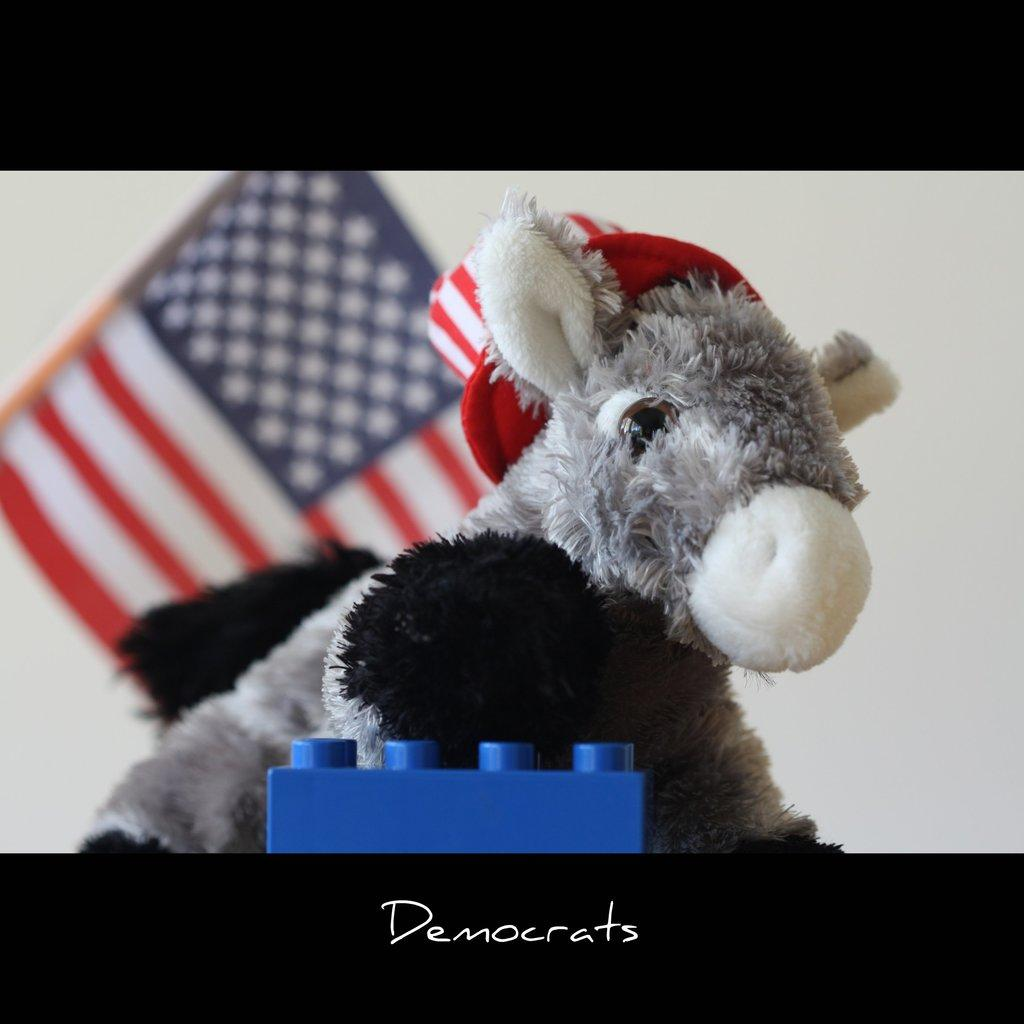What object can be seen in the image? There is a toy in the image. What is visible in the background of the image? There is a flag and a wall in the background of the image. Is there any text present in the image? Yes, there is some text at the bottom of the image. What type of chin can be seen supporting the toy in the image? There is no chin present in the image; it is a toy without any facial features. 